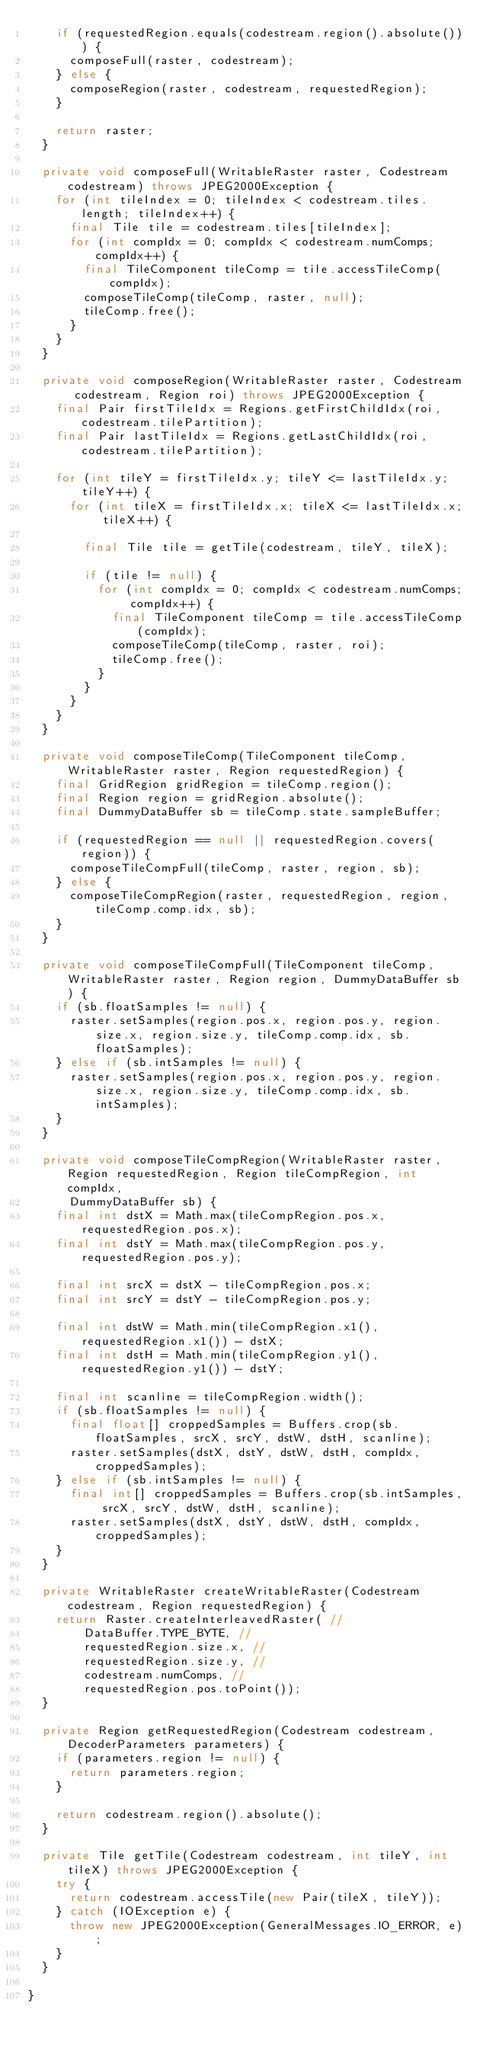Convert code to text. <code><loc_0><loc_0><loc_500><loc_500><_Java_>    if (requestedRegion.equals(codestream.region().absolute())) {
      composeFull(raster, codestream);
    } else {
      composeRegion(raster, codestream, requestedRegion);
    }

    return raster;
  }

  private void composeFull(WritableRaster raster, Codestream codestream) throws JPEG2000Exception {
    for (int tileIndex = 0; tileIndex < codestream.tiles.length; tileIndex++) {
      final Tile tile = codestream.tiles[tileIndex];
      for (int compIdx = 0; compIdx < codestream.numComps; compIdx++) {
        final TileComponent tileComp = tile.accessTileComp(compIdx);
        composeTileComp(tileComp, raster, null);
        tileComp.free();
      }
    }
  }

  private void composeRegion(WritableRaster raster, Codestream codestream, Region roi) throws JPEG2000Exception {
    final Pair firstTileIdx = Regions.getFirstChildIdx(roi, codestream.tilePartition);
    final Pair lastTileIdx = Regions.getLastChildIdx(roi, codestream.tilePartition);

    for (int tileY = firstTileIdx.y; tileY <= lastTileIdx.y; tileY++) {
      for (int tileX = firstTileIdx.x; tileX <= lastTileIdx.x; tileX++) {

        final Tile tile = getTile(codestream, tileY, tileX);

        if (tile != null) {
          for (int compIdx = 0; compIdx < codestream.numComps; compIdx++) {
            final TileComponent tileComp = tile.accessTileComp(compIdx);
            composeTileComp(tileComp, raster, roi);
            tileComp.free();
          }
        }
      }
    }
  }

  private void composeTileComp(TileComponent tileComp, WritableRaster raster, Region requestedRegion) {
    final GridRegion gridRegion = tileComp.region();
    final Region region = gridRegion.absolute();
    final DummyDataBuffer sb = tileComp.state.sampleBuffer;

    if (requestedRegion == null || requestedRegion.covers(region)) {
      composeTileCompFull(tileComp, raster, region, sb);
    } else {
      composeTileCompRegion(raster, requestedRegion, region, tileComp.comp.idx, sb);
    }
  }

  private void composeTileCompFull(TileComponent tileComp, WritableRaster raster, Region region, DummyDataBuffer sb) {
    if (sb.floatSamples != null) {
      raster.setSamples(region.pos.x, region.pos.y, region.size.x, region.size.y, tileComp.comp.idx, sb.floatSamples);
    } else if (sb.intSamples != null) {
      raster.setSamples(region.pos.x, region.pos.y, region.size.x, region.size.y, tileComp.comp.idx, sb.intSamples);
    }
  }

  private void composeTileCompRegion(WritableRaster raster, Region requestedRegion, Region tileCompRegion, int compIdx,
      DummyDataBuffer sb) {
    final int dstX = Math.max(tileCompRegion.pos.x, requestedRegion.pos.x);
    final int dstY = Math.max(tileCompRegion.pos.y, requestedRegion.pos.y);

    final int srcX = dstX - tileCompRegion.pos.x;
    final int srcY = dstY - tileCompRegion.pos.y;

    final int dstW = Math.min(tileCompRegion.x1(), requestedRegion.x1()) - dstX;
    final int dstH = Math.min(tileCompRegion.y1(), requestedRegion.y1()) - dstY;

    final int scanline = tileCompRegion.width();
    if (sb.floatSamples != null) {
      final float[] croppedSamples = Buffers.crop(sb.floatSamples, srcX, srcY, dstW, dstH, scanline);
      raster.setSamples(dstX, dstY, dstW, dstH, compIdx, croppedSamples);
    } else if (sb.intSamples != null) {
      final int[] croppedSamples = Buffers.crop(sb.intSamples, srcX, srcY, dstW, dstH, scanline);
      raster.setSamples(dstX, dstY, dstW, dstH, compIdx, croppedSamples);
    }
  }

  private WritableRaster createWritableRaster(Codestream codestream, Region requestedRegion) {
    return Raster.createInterleavedRaster( //
        DataBuffer.TYPE_BYTE, //
        requestedRegion.size.x, // 
        requestedRegion.size.y, // 
        codestream.numComps, //
        requestedRegion.pos.toPoint());
  }

  private Region getRequestedRegion(Codestream codestream, DecoderParameters parameters) {
    if (parameters.region != null) {
      return parameters.region;
    }

    return codestream.region().absolute();
  }

  private Tile getTile(Codestream codestream, int tileY, int tileX) throws JPEG2000Exception {
    try {
      return codestream.accessTile(new Pair(tileX, tileY));
    } catch (IOException e) {
      throw new JPEG2000Exception(GeneralMessages.IO_ERROR, e);
    }
  }

}
</code> 